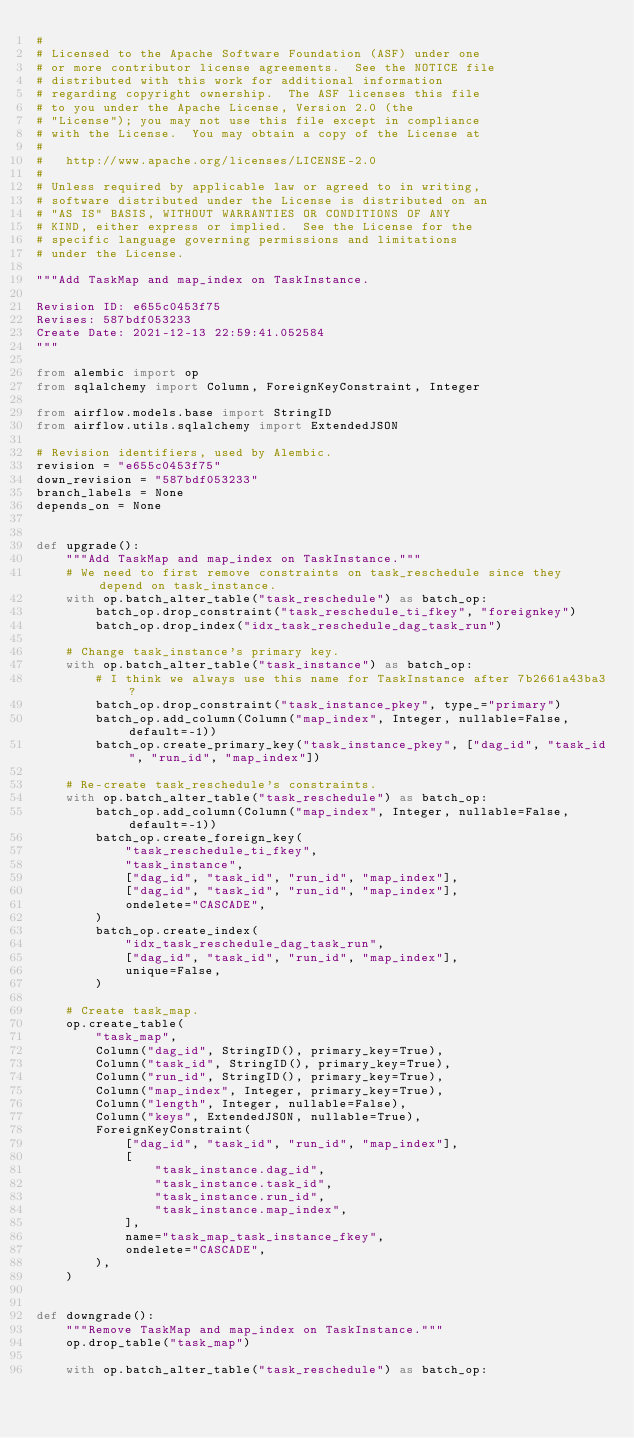<code> <loc_0><loc_0><loc_500><loc_500><_Python_>#
# Licensed to the Apache Software Foundation (ASF) under one
# or more contributor license agreements.  See the NOTICE file
# distributed with this work for additional information
# regarding copyright ownership.  The ASF licenses this file
# to you under the Apache License, Version 2.0 (the
# "License"); you may not use this file except in compliance
# with the License.  You may obtain a copy of the License at
#
#   http://www.apache.org/licenses/LICENSE-2.0
#
# Unless required by applicable law or agreed to in writing,
# software distributed under the License is distributed on an
# "AS IS" BASIS, WITHOUT WARRANTIES OR CONDITIONS OF ANY
# KIND, either express or implied.  See the License for the
# specific language governing permissions and limitations
# under the License.

"""Add TaskMap and map_index on TaskInstance.

Revision ID: e655c0453f75
Revises: 587bdf053233
Create Date: 2021-12-13 22:59:41.052584
"""

from alembic import op
from sqlalchemy import Column, ForeignKeyConstraint, Integer

from airflow.models.base import StringID
from airflow.utils.sqlalchemy import ExtendedJSON

# Revision identifiers, used by Alembic.
revision = "e655c0453f75"
down_revision = "587bdf053233"
branch_labels = None
depends_on = None


def upgrade():
    """Add TaskMap and map_index on TaskInstance."""
    # We need to first remove constraints on task_reschedule since they depend on task_instance.
    with op.batch_alter_table("task_reschedule") as batch_op:
        batch_op.drop_constraint("task_reschedule_ti_fkey", "foreignkey")
        batch_op.drop_index("idx_task_reschedule_dag_task_run")

    # Change task_instance's primary key.
    with op.batch_alter_table("task_instance") as batch_op:
        # I think we always use this name for TaskInstance after 7b2661a43ba3?
        batch_op.drop_constraint("task_instance_pkey", type_="primary")
        batch_op.add_column(Column("map_index", Integer, nullable=False, default=-1))
        batch_op.create_primary_key("task_instance_pkey", ["dag_id", "task_id", "run_id", "map_index"])

    # Re-create task_reschedule's constraints.
    with op.batch_alter_table("task_reschedule") as batch_op:
        batch_op.add_column(Column("map_index", Integer, nullable=False, default=-1))
        batch_op.create_foreign_key(
            "task_reschedule_ti_fkey",
            "task_instance",
            ["dag_id", "task_id", "run_id", "map_index"],
            ["dag_id", "task_id", "run_id", "map_index"],
            ondelete="CASCADE",
        )
        batch_op.create_index(
            "idx_task_reschedule_dag_task_run",
            ["dag_id", "task_id", "run_id", "map_index"],
            unique=False,
        )

    # Create task_map.
    op.create_table(
        "task_map",
        Column("dag_id", StringID(), primary_key=True),
        Column("task_id", StringID(), primary_key=True),
        Column("run_id", StringID(), primary_key=True),
        Column("map_index", Integer, primary_key=True),
        Column("length", Integer, nullable=False),
        Column("keys", ExtendedJSON, nullable=True),
        ForeignKeyConstraint(
            ["dag_id", "task_id", "run_id", "map_index"],
            [
                "task_instance.dag_id",
                "task_instance.task_id",
                "task_instance.run_id",
                "task_instance.map_index",
            ],
            name="task_map_task_instance_fkey",
            ondelete="CASCADE",
        ),
    )


def downgrade():
    """Remove TaskMap and map_index on TaskInstance."""
    op.drop_table("task_map")

    with op.batch_alter_table("task_reschedule") as batch_op:</code> 